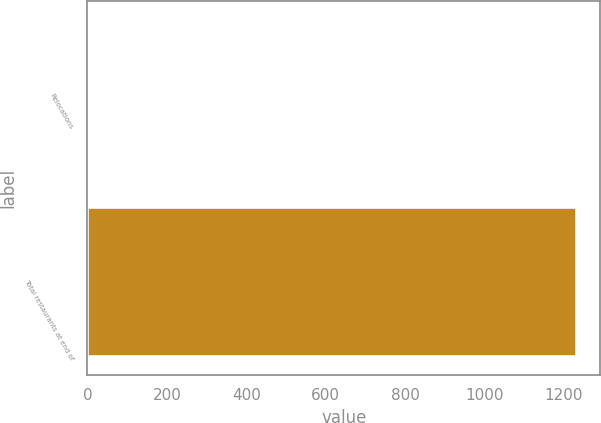<chart> <loc_0><loc_0><loc_500><loc_500><bar_chart><fcel>Relocations<fcel>Total restaurants at end of<nl><fcel>4<fcel>1230<nl></chart> 